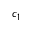<formula> <loc_0><loc_0><loc_500><loc_500>c _ { 1 }</formula> 